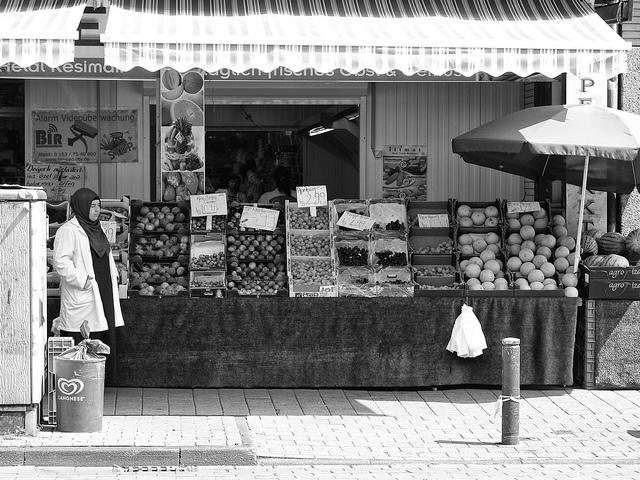Is the woman sitting?
Concise answer only. No. What kind of stand is this?
Give a very brief answer. Fruit. Is the woman wearing a headscarf?
Keep it brief. Yes. 